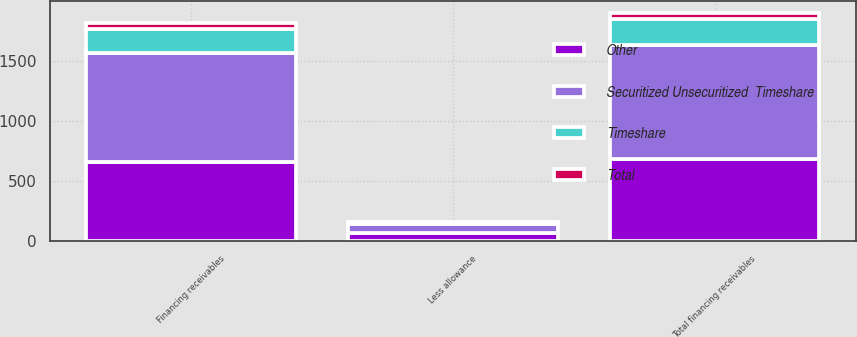Convert chart. <chart><loc_0><loc_0><loc_500><loc_500><stacked_bar_chart><ecel><fcel>Financing receivables<fcel>Less allowance<fcel>Total financing receivables<nl><fcel>Timeshare<fcel>205<fcel>11<fcel>221<nl><fcel>Other<fcel>654<fcel>67<fcel>681<nl><fcel>Total<fcel>49<fcel>1<fcel>48<nl><fcel>Securitized Unsecuritized  Timeshare<fcel>908<fcel>79<fcel>950<nl></chart> 